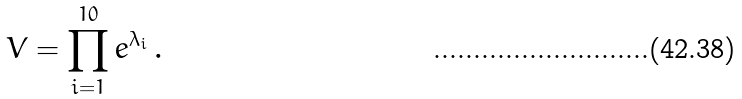Convert formula to latex. <formula><loc_0><loc_0><loc_500><loc_500>V = \prod ^ { 1 0 } _ { i = 1 } e ^ { \lambda _ { i } } \, .</formula> 